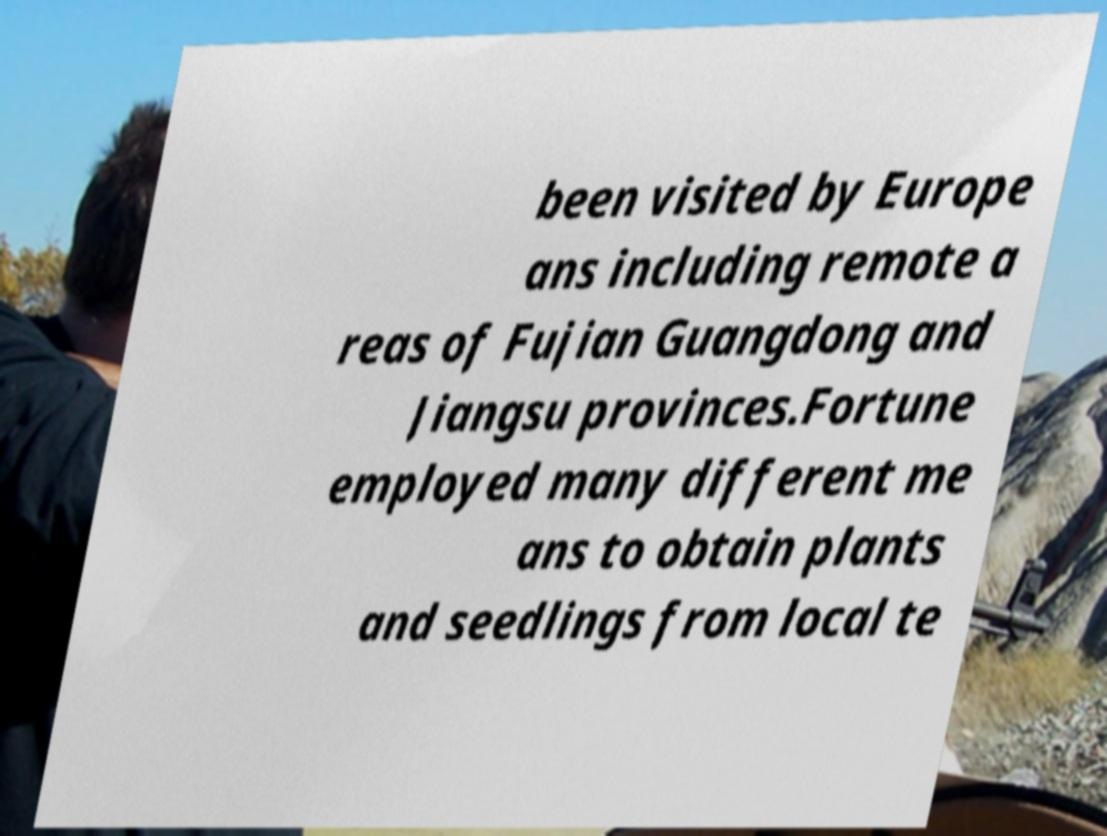What messages or text are displayed in this image? I need them in a readable, typed format. been visited by Europe ans including remote a reas of Fujian Guangdong and Jiangsu provinces.Fortune employed many different me ans to obtain plants and seedlings from local te 